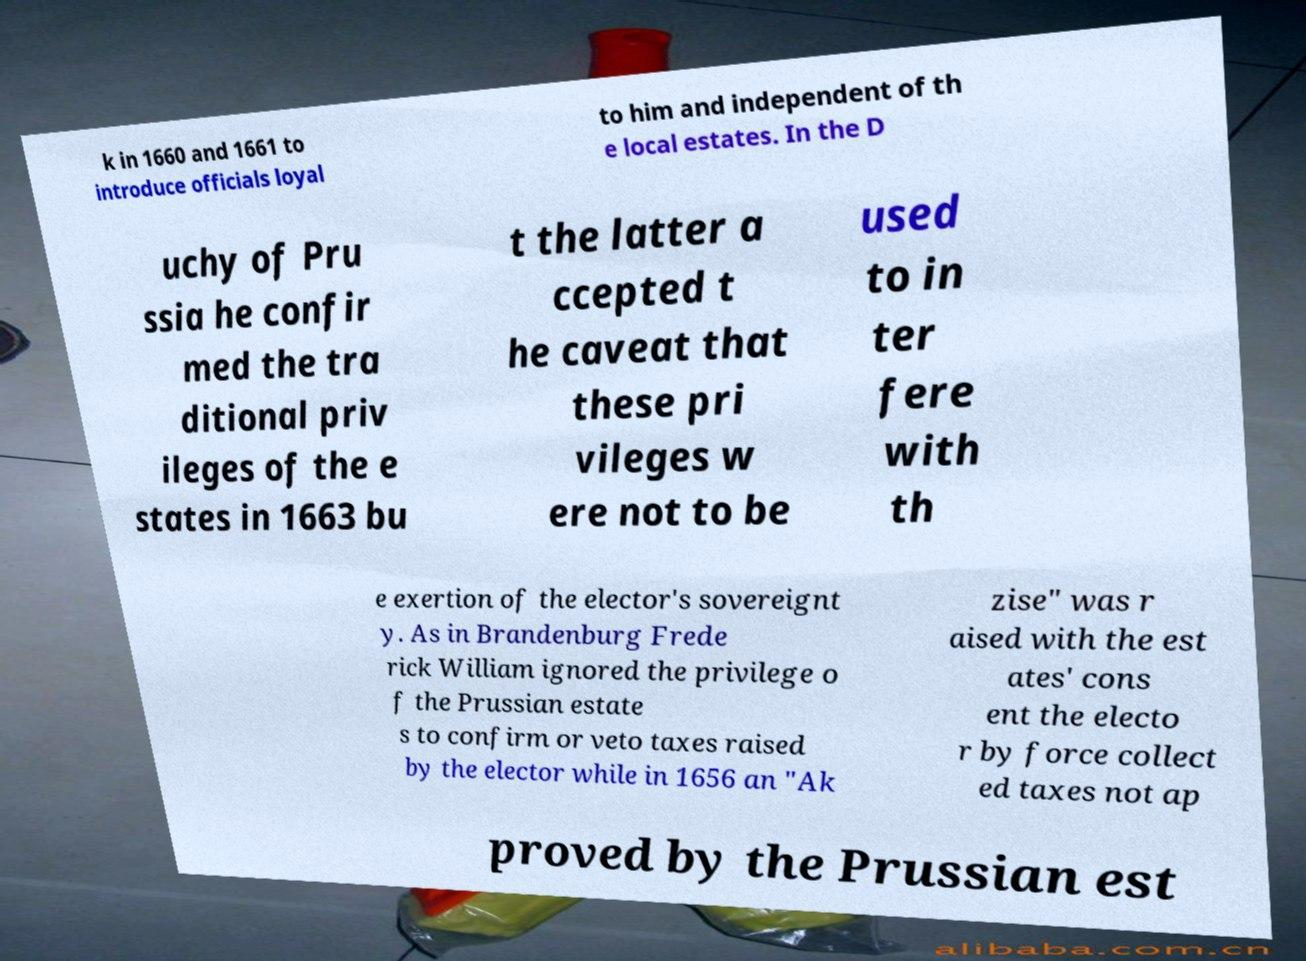Can you read and provide the text displayed in the image?This photo seems to have some interesting text. Can you extract and type it out for me? k in 1660 and 1661 to introduce officials loyal to him and independent of th e local estates. In the D uchy of Pru ssia he confir med the tra ditional priv ileges of the e states in 1663 bu t the latter a ccepted t he caveat that these pri vileges w ere not to be used to in ter fere with th e exertion of the elector's sovereignt y. As in Brandenburg Frede rick William ignored the privilege o f the Prussian estate s to confirm or veto taxes raised by the elector while in 1656 an "Ak zise" was r aised with the est ates' cons ent the electo r by force collect ed taxes not ap proved by the Prussian est 